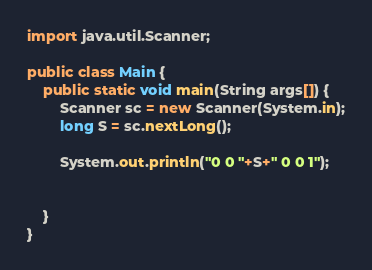Convert code to text. <code><loc_0><loc_0><loc_500><loc_500><_Java_>import java.util.Scanner;

public class Main {
	public static void main(String args[]) {
		Scanner sc = new Scanner(System.in);
		long S = sc.nextLong();

		System.out.println("0 0 "+S+" 0 0 1");


	}
}
</code> 